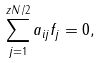<formula> <loc_0><loc_0><loc_500><loc_500>\sum _ { j = 1 } ^ { z N / 2 } a _ { i j } f _ { j } = 0 ,</formula> 